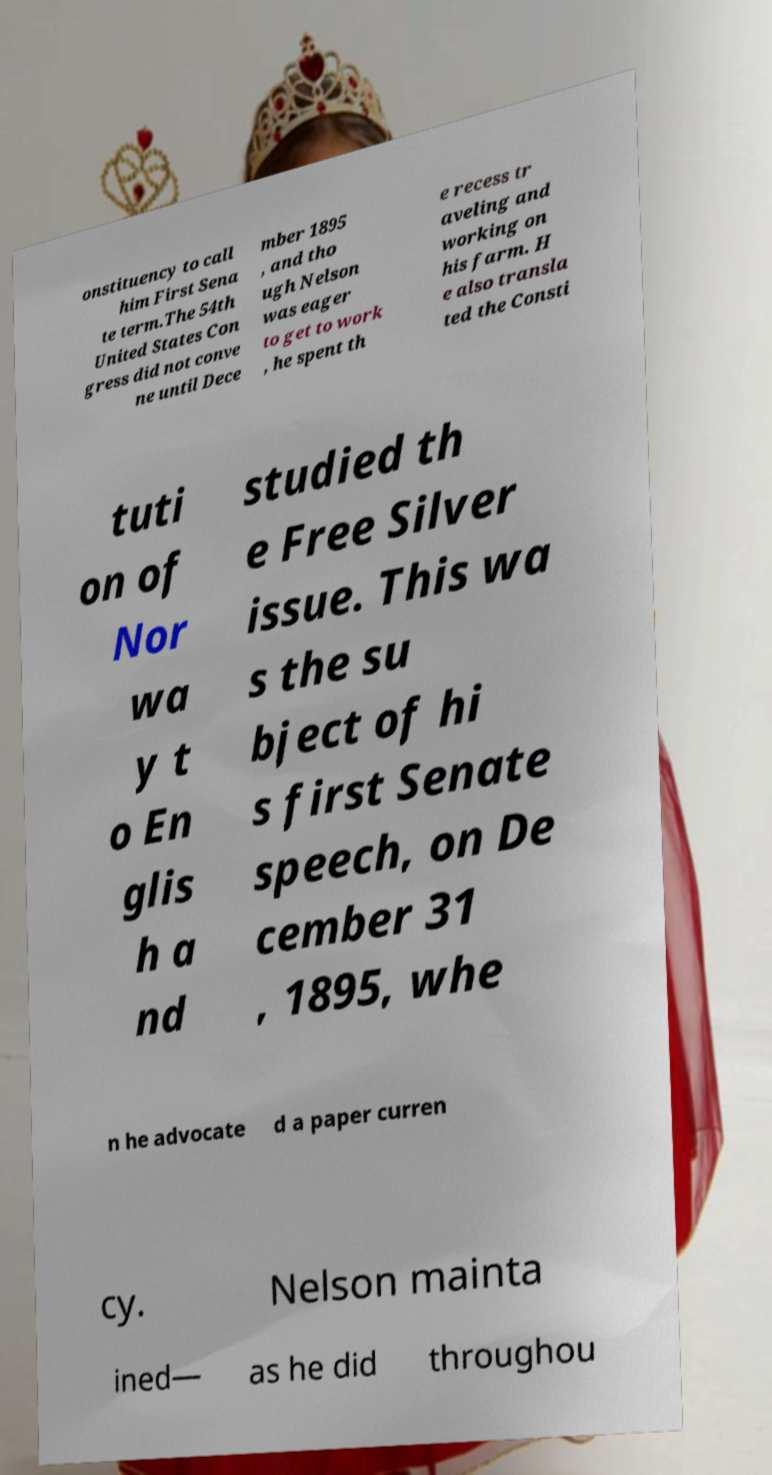Please read and relay the text visible in this image. What does it say? onstituency to call him First Sena te term.The 54th United States Con gress did not conve ne until Dece mber 1895 , and tho ugh Nelson was eager to get to work , he spent th e recess tr aveling and working on his farm. H e also transla ted the Consti tuti on of Nor wa y t o En glis h a nd studied th e Free Silver issue. This wa s the su bject of hi s first Senate speech, on De cember 31 , 1895, whe n he advocate d a paper curren cy. Nelson mainta ined— as he did throughou 